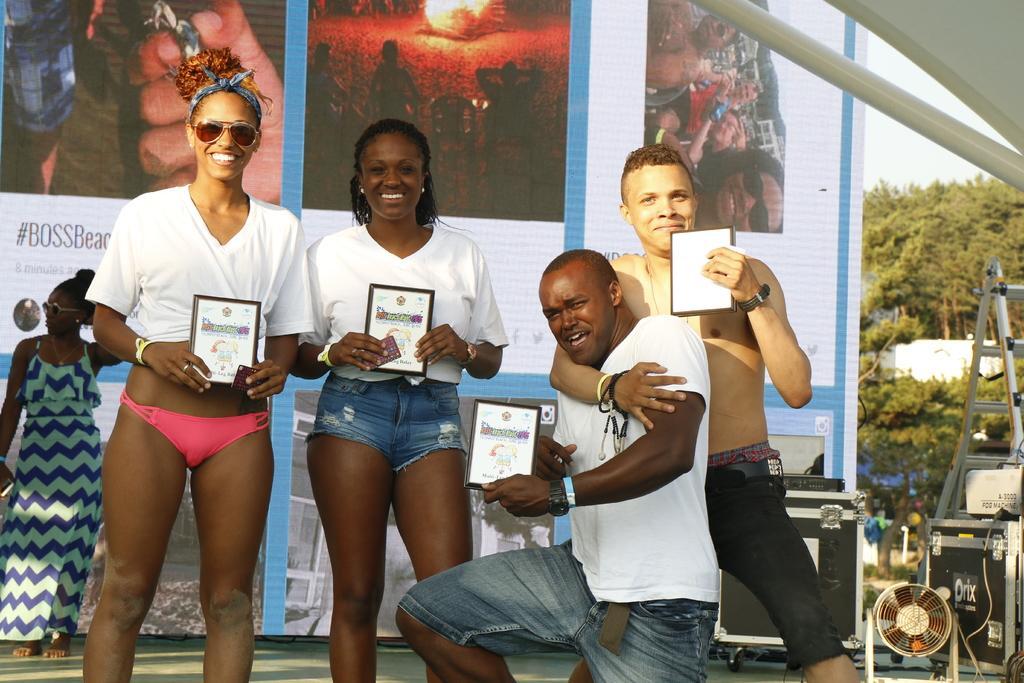Please provide a concise description of this image. In this image I can see the group of people with different color dresses. I can see two people with the goggles. I can see few people are holding the boards. In the background I can see the banner. To the right I can see some black color object, fan, metal rod, trees and the sky. 